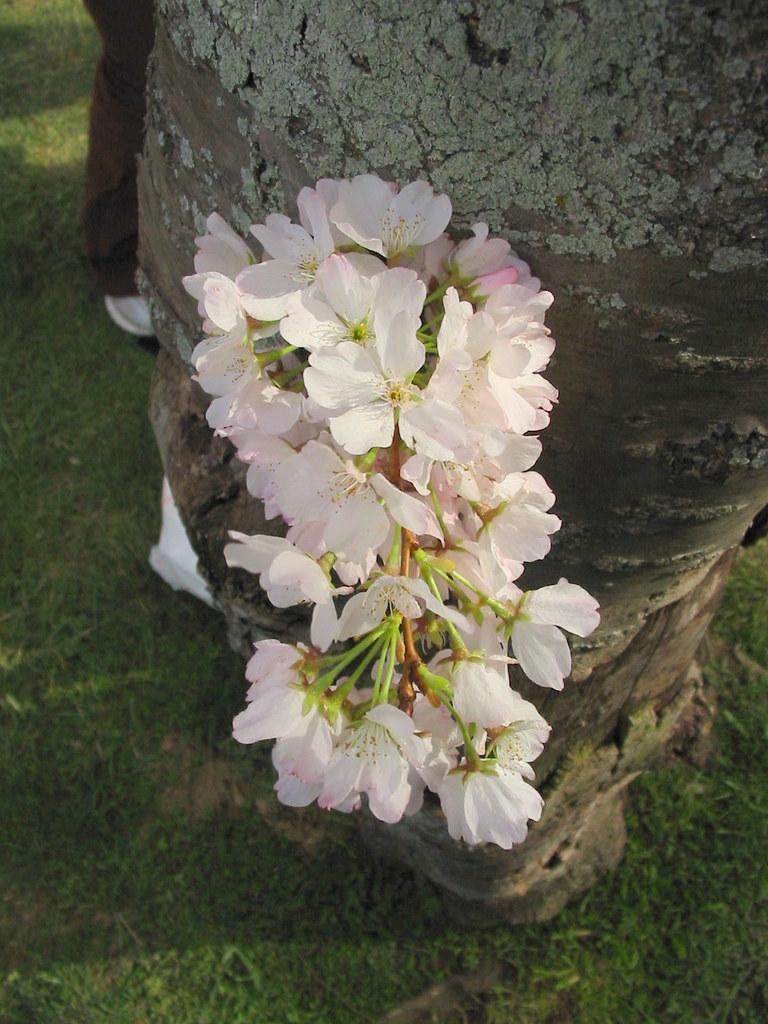What is the main subject in the center of the image? There are flowers in the center of the image. What can be seen in the background of the image? There is a tree and persons in the background of the image. What type of vegetation is at the bottom of the image? There is grass at the bottom of the image. How does the surprise appear in the image? There is no surprise present in the image; it is a scene featuring flowers, a tree, persons, and grass. 